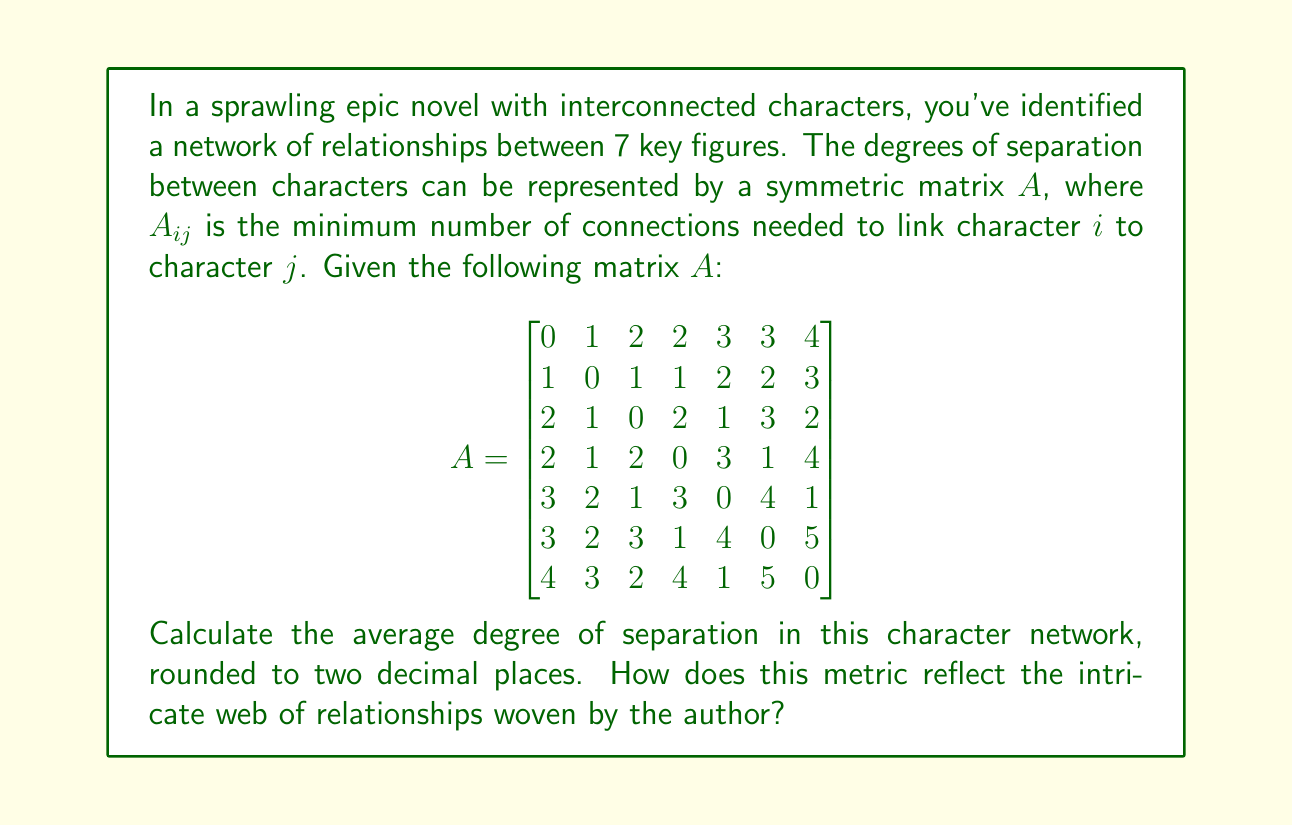Show me your answer to this math problem. To solve this problem and understand the intricacy of the character relationships, we'll follow these steps:

1) First, we need to sum all the elements in the matrix. However, since the matrix is symmetric and the diagonal elements are always 0 (a character has 0 degrees of separation from themselves), we can simplify our calculation.

2) Let's sum the upper triangular part of the matrix (excluding the diagonal):

   $S = 1 + 2 + 2 + 3 + 3 + 4 + 1 + 1 + 2 + 2 + 3 + 2 + 3 + 1 + 2 + 3 + 1 + 4 + 1 + 5 + 1$

3) $S = 47$

4) Since the matrix is symmetric, the total sum of all non-diagonal elements is $2S = 2 * 47 = 94$

5) To calculate the average, we need to divide this sum by the total number of non-diagonal elements. In a 7x7 matrix, there are $7 * 6 = 42$ non-diagonal elements.

6) The average degree of separation is thus:

   $\text{Average} = \frac{94}{42} = 2.2380952...$

7) Rounding to two decimal places, we get 2.24.

This average of 2.24 degrees of separation reflects a tightly woven narrative where characters are closely interconnected. In literary terms, it suggests that the author has crafted a dense network of relationships, where most characters are linked through just two or three intermediary connections. This creates a rich tapestry of intertwined destinies, allowing for complex plot developments and character interactions that can ripple through the entire cast.
Answer: 2.24 